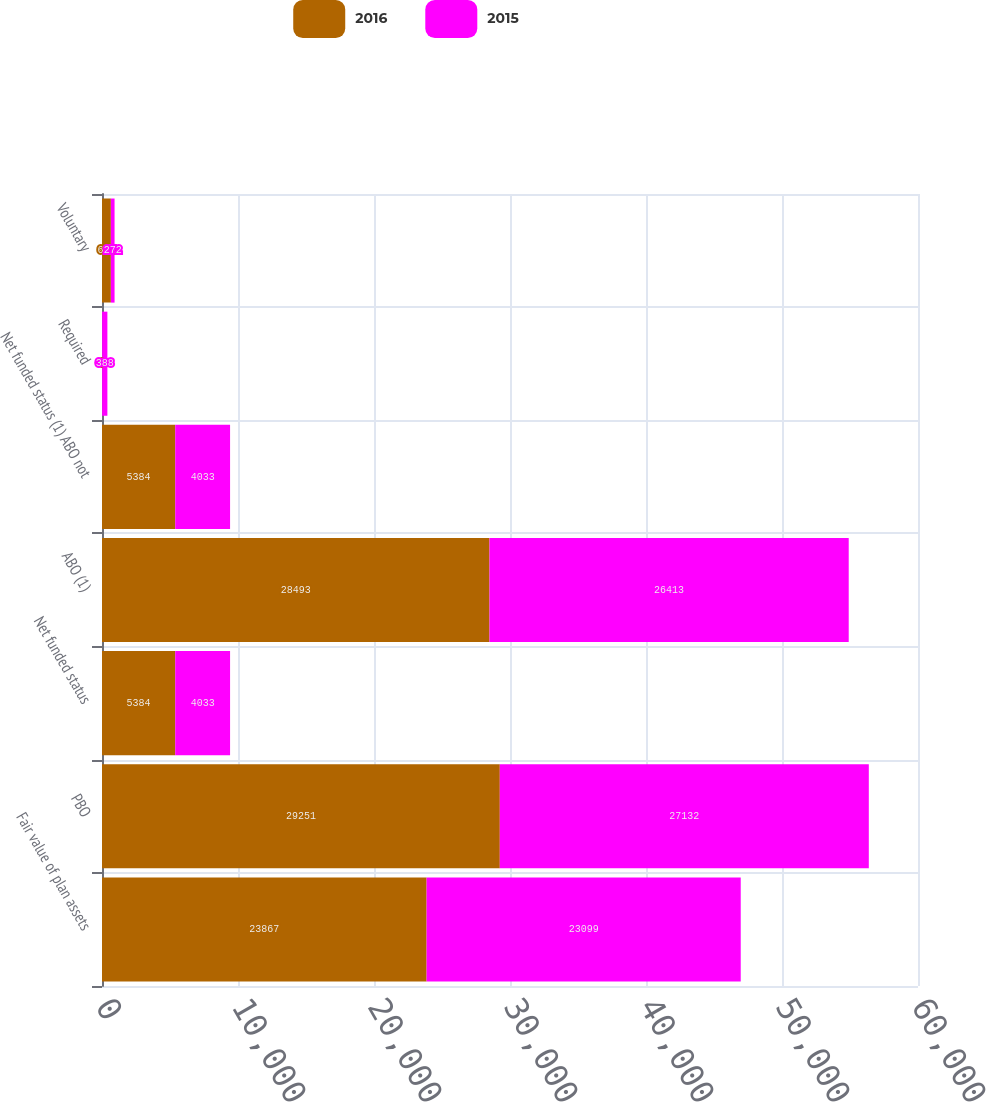Convert chart. <chart><loc_0><loc_0><loc_500><loc_500><stacked_bar_chart><ecel><fcel>Fair value of plan assets<fcel>PBO<fcel>Net funded status<fcel>ABO (1)<fcel>Net funded status (1) ABO not<fcel>Required<fcel>Voluntary<nl><fcel>2016<fcel>23867<fcel>29251<fcel>5384<fcel>28493<fcel>5384<fcel>8<fcel>652<nl><fcel>2015<fcel>23099<fcel>27132<fcel>4033<fcel>26413<fcel>4033<fcel>388<fcel>272<nl></chart> 